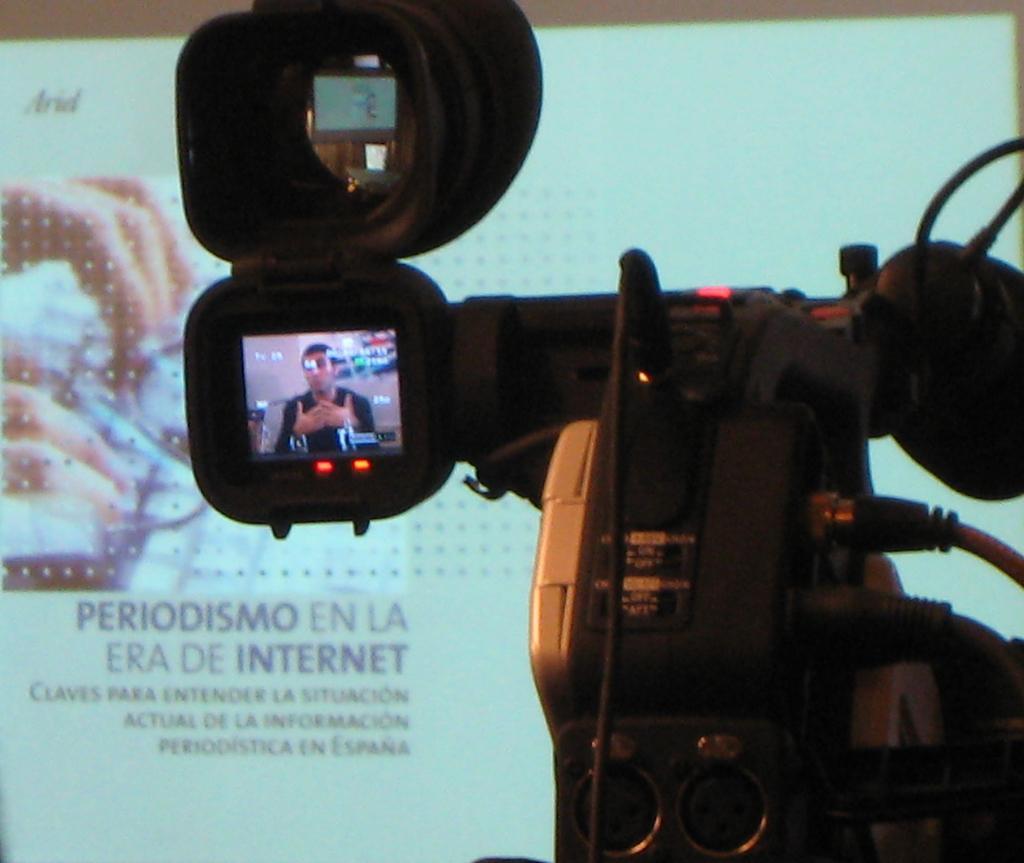Please provide a concise description of this image. In this image we can see a video camera and there is a person on the camera display and in the background, we can see the projector screen with some text and the picture. 